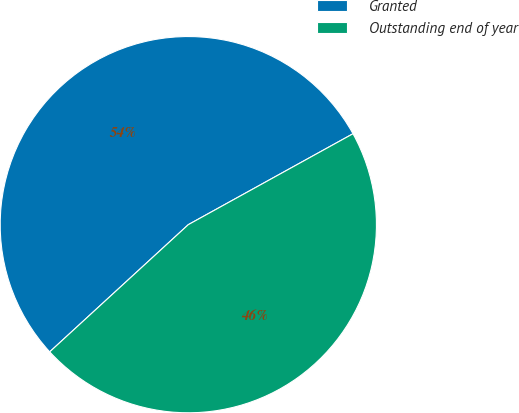<chart> <loc_0><loc_0><loc_500><loc_500><pie_chart><fcel>Granted<fcel>Outstanding end of year<nl><fcel>53.79%<fcel>46.21%<nl></chart> 